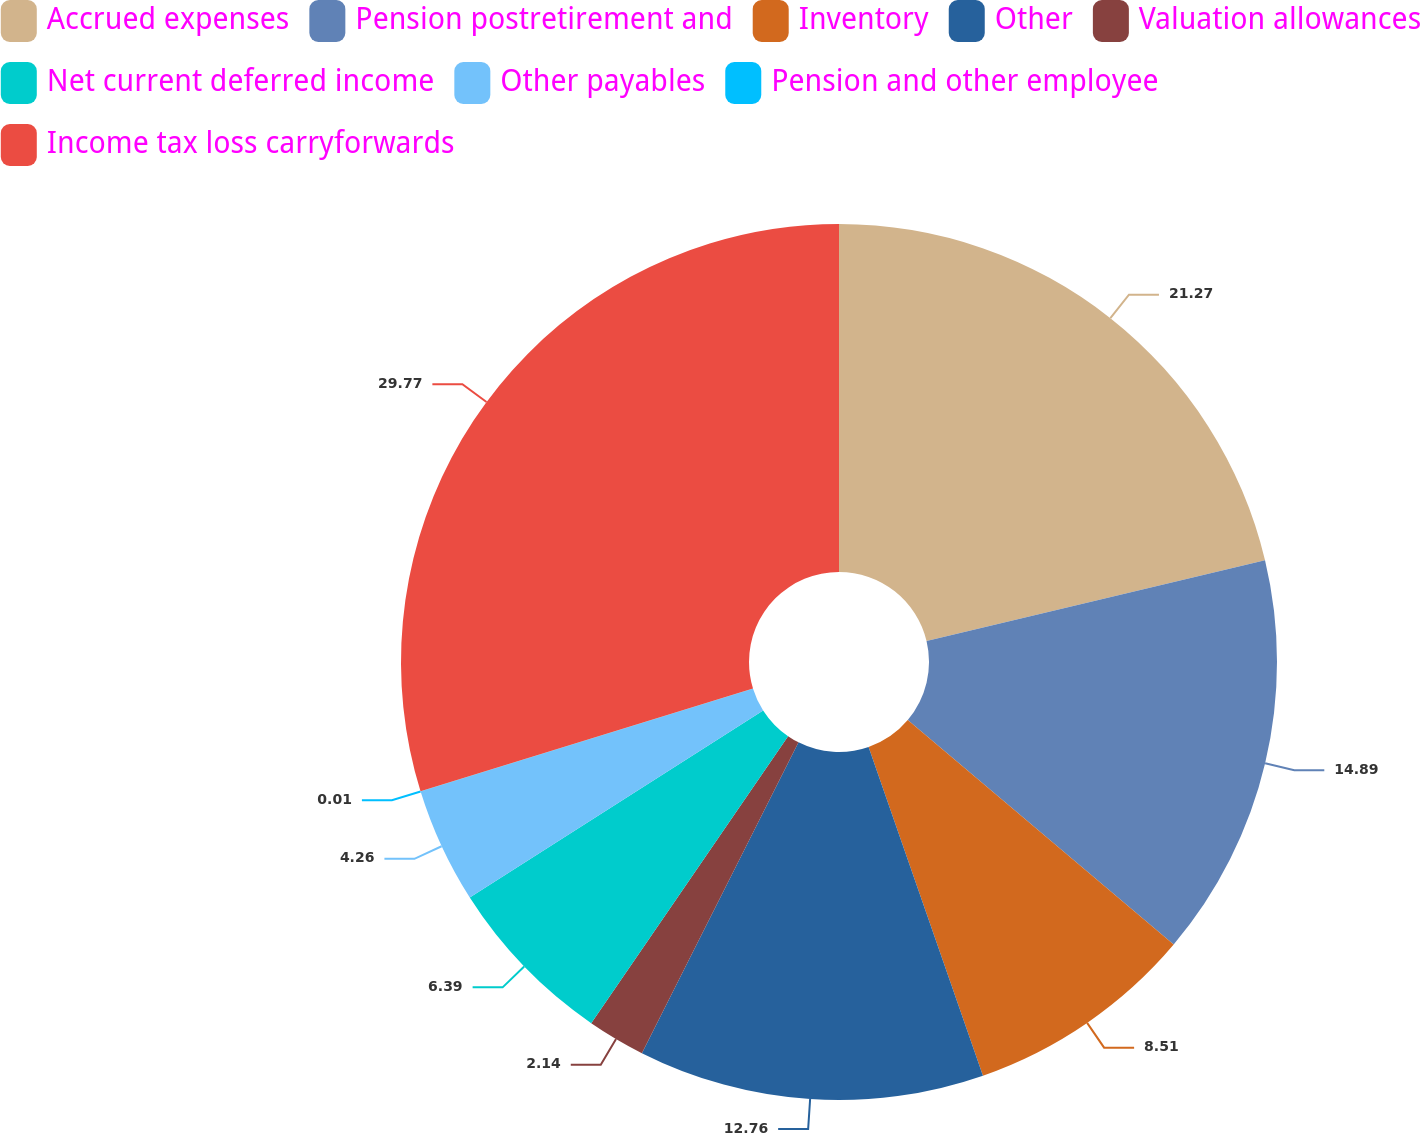<chart> <loc_0><loc_0><loc_500><loc_500><pie_chart><fcel>Accrued expenses<fcel>Pension postretirement and<fcel>Inventory<fcel>Other<fcel>Valuation allowances<fcel>Net current deferred income<fcel>Other payables<fcel>Pension and other employee<fcel>Income tax loss carryforwards<nl><fcel>21.27%<fcel>14.89%<fcel>8.51%<fcel>12.76%<fcel>2.14%<fcel>6.39%<fcel>4.26%<fcel>0.01%<fcel>29.77%<nl></chart> 